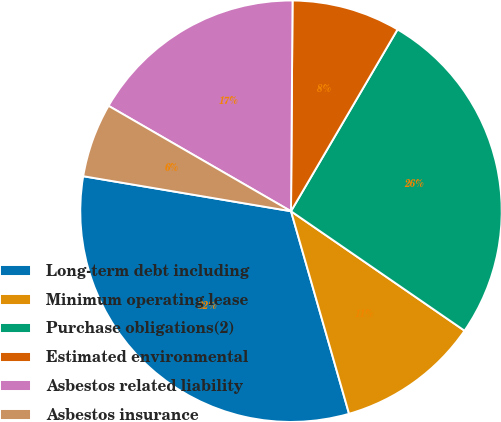Convert chart. <chart><loc_0><loc_0><loc_500><loc_500><pie_chart><fcel>Long-term debt including<fcel>Minimum operating lease<fcel>Purchase obligations(2)<fcel>Estimated environmental<fcel>Asbestos related liability<fcel>Asbestos insurance<nl><fcel>32.1%<fcel>10.96%<fcel>26.16%<fcel>8.32%<fcel>16.78%<fcel>5.68%<nl></chart> 